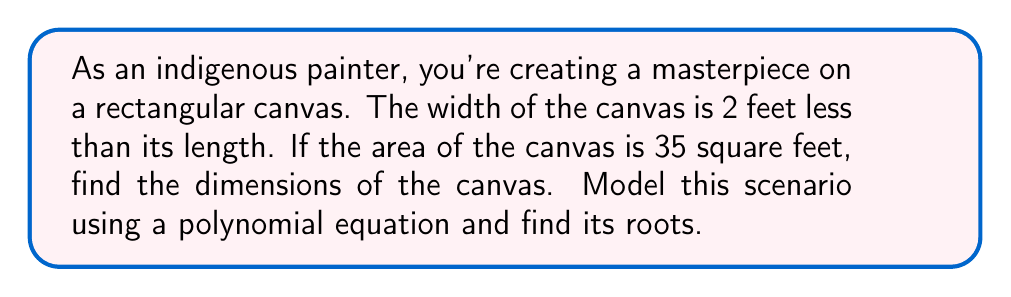Solve this math problem. Let's approach this step-by-step:

1) Let the length of the canvas be $x$ feet.

2) Then, the width is $(x-2)$ feet.

3) The area of a rectangle is length times width. So we can write:

   $x(x-2) = 35$

4) Expanding this equation:

   $x^2 - 2x = 35$

5) Rearranging to standard form:

   $x^2 - 2x - 35 = 0$

6) This is a quadratic equation. We can solve it using the quadratic formula:

   $x = \frac{-b \pm \sqrt{b^2 - 4ac}}{2a}$

   Where $a=1$, $b=-2$, and $c=-35$

7) Substituting these values:

   $x = \frac{2 \pm \sqrt{(-2)^2 - 4(1)(-35)}}{2(1)}$

8) Simplifying:

   $x = \frac{2 \pm \sqrt{4 + 140}}{2} = \frac{2 \pm \sqrt{144}}{2} = \frac{2 \pm 12}{2}$

9) This gives us two solutions:

   $x = \frac{2 + 12}{2} = 7$ or $x = \frac{2 - 12}{2} = -5$

10) Since length cannot be negative, we discard the negative solution.

Therefore, the length of the canvas is 7 feet, and the width is $7-2 = 5$ feet.
Answer: The roots of the polynomial equation $x^2 - 2x - 35 = 0$ are $x = 7$ and $x = -5$. The dimensions of the canvas are 7 feet long and 5 feet wide. 